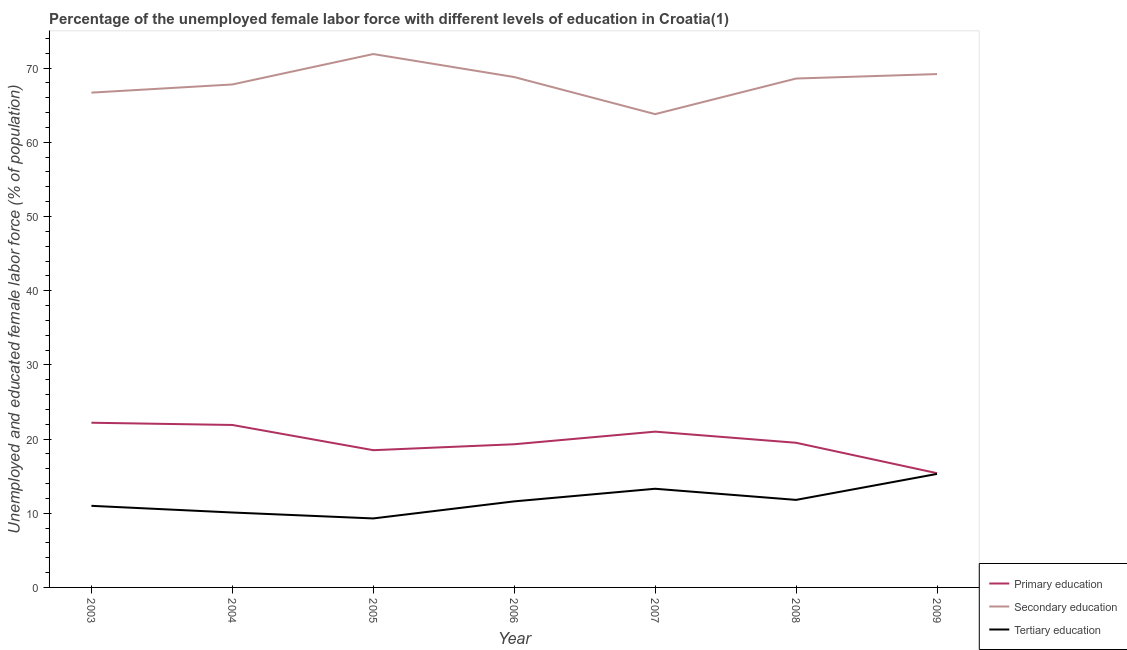Is the number of lines equal to the number of legend labels?
Offer a very short reply. Yes. What is the percentage of female labor force who received secondary education in 2009?
Ensure brevity in your answer.  69.2. Across all years, what is the maximum percentage of female labor force who received tertiary education?
Your answer should be very brief. 15.3. Across all years, what is the minimum percentage of female labor force who received secondary education?
Offer a very short reply. 63.8. What is the total percentage of female labor force who received tertiary education in the graph?
Provide a succinct answer. 82.4. What is the difference between the percentage of female labor force who received secondary education in 2005 and that in 2009?
Give a very brief answer. 2.7. What is the difference between the percentage of female labor force who received primary education in 2007 and the percentage of female labor force who received tertiary education in 2006?
Keep it short and to the point. 9.4. What is the average percentage of female labor force who received primary education per year?
Keep it short and to the point. 19.69. In the year 2008, what is the difference between the percentage of female labor force who received primary education and percentage of female labor force who received tertiary education?
Ensure brevity in your answer.  7.7. What is the ratio of the percentage of female labor force who received tertiary education in 2008 to that in 2009?
Offer a terse response. 0.77. Is the difference between the percentage of female labor force who received primary education in 2005 and 2006 greater than the difference between the percentage of female labor force who received tertiary education in 2005 and 2006?
Make the answer very short. Yes. What is the difference between the highest and the second highest percentage of female labor force who received secondary education?
Make the answer very short. 2.7. What is the difference between the highest and the lowest percentage of female labor force who received tertiary education?
Make the answer very short. 6. Does the percentage of female labor force who received primary education monotonically increase over the years?
Your answer should be compact. No. Is the percentage of female labor force who received primary education strictly less than the percentage of female labor force who received secondary education over the years?
Give a very brief answer. Yes. How many years are there in the graph?
Provide a short and direct response. 7. What is the difference between two consecutive major ticks on the Y-axis?
Offer a very short reply. 10. Does the graph contain any zero values?
Provide a succinct answer. No. How are the legend labels stacked?
Offer a terse response. Vertical. What is the title of the graph?
Provide a short and direct response. Percentage of the unemployed female labor force with different levels of education in Croatia(1). What is the label or title of the X-axis?
Ensure brevity in your answer.  Year. What is the label or title of the Y-axis?
Give a very brief answer. Unemployed and educated female labor force (% of population). What is the Unemployed and educated female labor force (% of population) of Primary education in 2003?
Keep it short and to the point. 22.2. What is the Unemployed and educated female labor force (% of population) of Secondary education in 2003?
Make the answer very short. 66.7. What is the Unemployed and educated female labor force (% of population) of Tertiary education in 2003?
Your response must be concise. 11. What is the Unemployed and educated female labor force (% of population) of Primary education in 2004?
Keep it short and to the point. 21.9. What is the Unemployed and educated female labor force (% of population) of Secondary education in 2004?
Ensure brevity in your answer.  67.8. What is the Unemployed and educated female labor force (% of population) of Tertiary education in 2004?
Offer a terse response. 10.1. What is the Unemployed and educated female labor force (% of population) in Primary education in 2005?
Your answer should be compact. 18.5. What is the Unemployed and educated female labor force (% of population) in Secondary education in 2005?
Offer a very short reply. 71.9. What is the Unemployed and educated female labor force (% of population) of Tertiary education in 2005?
Give a very brief answer. 9.3. What is the Unemployed and educated female labor force (% of population) in Primary education in 2006?
Provide a short and direct response. 19.3. What is the Unemployed and educated female labor force (% of population) of Secondary education in 2006?
Provide a short and direct response. 68.8. What is the Unemployed and educated female labor force (% of population) in Tertiary education in 2006?
Provide a short and direct response. 11.6. What is the Unemployed and educated female labor force (% of population) in Primary education in 2007?
Offer a terse response. 21. What is the Unemployed and educated female labor force (% of population) of Secondary education in 2007?
Offer a terse response. 63.8. What is the Unemployed and educated female labor force (% of population) in Tertiary education in 2007?
Your answer should be very brief. 13.3. What is the Unemployed and educated female labor force (% of population) in Secondary education in 2008?
Your answer should be compact. 68.6. What is the Unemployed and educated female labor force (% of population) in Tertiary education in 2008?
Make the answer very short. 11.8. What is the Unemployed and educated female labor force (% of population) in Primary education in 2009?
Provide a short and direct response. 15.4. What is the Unemployed and educated female labor force (% of population) of Secondary education in 2009?
Your answer should be compact. 69.2. What is the Unemployed and educated female labor force (% of population) in Tertiary education in 2009?
Provide a short and direct response. 15.3. Across all years, what is the maximum Unemployed and educated female labor force (% of population) in Primary education?
Your answer should be compact. 22.2. Across all years, what is the maximum Unemployed and educated female labor force (% of population) in Secondary education?
Offer a terse response. 71.9. Across all years, what is the maximum Unemployed and educated female labor force (% of population) of Tertiary education?
Offer a very short reply. 15.3. Across all years, what is the minimum Unemployed and educated female labor force (% of population) in Primary education?
Provide a short and direct response. 15.4. Across all years, what is the minimum Unemployed and educated female labor force (% of population) in Secondary education?
Make the answer very short. 63.8. Across all years, what is the minimum Unemployed and educated female labor force (% of population) of Tertiary education?
Your answer should be very brief. 9.3. What is the total Unemployed and educated female labor force (% of population) of Primary education in the graph?
Your response must be concise. 137.8. What is the total Unemployed and educated female labor force (% of population) in Secondary education in the graph?
Offer a very short reply. 476.8. What is the total Unemployed and educated female labor force (% of population) in Tertiary education in the graph?
Make the answer very short. 82.4. What is the difference between the Unemployed and educated female labor force (% of population) in Primary education in 2003 and that in 2004?
Give a very brief answer. 0.3. What is the difference between the Unemployed and educated female labor force (% of population) of Tertiary education in 2003 and that in 2004?
Provide a short and direct response. 0.9. What is the difference between the Unemployed and educated female labor force (% of population) in Tertiary education in 2003 and that in 2005?
Your answer should be very brief. 1.7. What is the difference between the Unemployed and educated female labor force (% of population) in Primary education in 2003 and that in 2006?
Make the answer very short. 2.9. What is the difference between the Unemployed and educated female labor force (% of population) in Tertiary education in 2003 and that in 2006?
Make the answer very short. -0.6. What is the difference between the Unemployed and educated female labor force (% of population) in Secondary education in 2003 and that in 2007?
Ensure brevity in your answer.  2.9. What is the difference between the Unemployed and educated female labor force (% of population) in Primary education in 2003 and that in 2008?
Ensure brevity in your answer.  2.7. What is the difference between the Unemployed and educated female labor force (% of population) of Secondary education in 2003 and that in 2008?
Ensure brevity in your answer.  -1.9. What is the difference between the Unemployed and educated female labor force (% of population) in Primary education in 2003 and that in 2009?
Give a very brief answer. 6.8. What is the difference between the Unemployed and educated female labor force (% of population) of Secondary education in 2003 and that in 2009?
Offer a very short reply. -2.5. What is the difference between the Unemployed and educated female labor force (% of population) of Secondary education in 2004 and that in 2005?
Keep it short and to the point. -4.1. What is the difference between the Unemployed and educated female labor force (% of population) of Tertiary education in 2004 and that in 2005?
Keep it short and to the point. 0.8. What is the difference between the Unemployed and educated female labor force (% of population) in Primary education in 2004 and that in 2006?
Your response must be concise. 2.6. What is the difference between the Unemployed and educated female labor force (% of population) in Tertiary education in 2004 and that in 2006?
Offer a very short reply. -1.5. What is the difference between the Unemployed and educated female labor force (% of population) of Primary education in 2004 and that in 2007?
Offer a terse response. 0.9. What is the difference between the Unemployed and educated female labor force (% of population) in Primary education in 2004 and that in 2008?
Provide a short and direct response. 2.4. What is the difference between the Unemployed and educated female labor force (% of population) in Tertiary education in 2004 and that in 2008?
Ensure brevity in your answer.  -1.7. What is the difference between the Unemployed and educated female labor force (% of population) in Secondary education in 2004 and that in 2009?
Your answer should be compact. -1.4. What is the difference between the Unemployed and educated female labor force (% of population) in Primary education in 2005 and that in 2007?
Offer a very short reply. -2.5. What is the difference between the Unemployed and educated female labor force (% of population) of Secondary education in 2005 and that in 2008?
Your answer should be very brief. 3.3. What is the difference between the Unemployed and educated female labor force (% of population) of Secondary education in 2005 and that in 2009?
Your answer should be compact. 2.7. What is the difference between the Unemployed and educated female labor force (% of population) of Primary education in 2006 and that in 2007?
Keep it short and to the point. -1.7. What is the difference between the Unemployed and educated female labor force (% of population) of Secondary education in 2006 and that in 2007?
Your answer should be compact. 5. What is the difference between the Unemployed and educated female labor force (% of population) in Tertiary education in 2006 and that in 2007?
Offer a terse response. -1.7. What is the difference between the Unemployed and educated female labor force (% of population) in Tertiary education in 2006 and that in 2008?
Your answer should be compact. -0.2. What is the difference between the Unemployed and educated female labor force (% of population) in Secondary education in 2006 and that in 2009?
Provide a succinct answer. -0.4. What is the difference between the Unemployed and educated female labor force (% of population) of Primary education in 2007 and that in 2008?
Give a very brief answer. 1.5. What is the difference between the Unemployed and educated female labor force (% of population) of Secondary education in 2007 and that in 2009?
Your response must be concise. -5.4. What is the difference between the Unemployed and educated female labor force (% of population) of Tertiary education in 2007 and that in 2009?
Offer a terse response. -2. What is the difference between the Unemployed and educated female labor force (% of population) of Tertiary education in 2008 and that in 2009?
Your answer should be very brief. -3.5. What is the difference between the Unemployed and educated female labor force (% of population) of Primary education in 2003 and the Unemployed and educated female labor force (% of population) of Secondary education in 2004?
Provide a succinct answer. -45.6. What is the difference between the Unemployed and educated female labor force (% of population) in Secondary education in 2003 and the Unemployed and educated female labor force (% of population) in Tertiary education in 2004?
Give a very brief answer. 56.6. What is the difference between the Unemployed and educated female labor force (% of population) of Primary education in 2003 and the Unemployed and educated female labor force (% of population) of Secondary education in 2005?
Your answer should be very brief. -49.7. What is the difference between the Unemployed and educated female labor force (% of population) in Primary education in 2003 and the Unemployed and educated female labor force (% of population) in Tertiary education in 2005?
Your response must be concise. 12.9. What is the difference between the Unemployed and educated female labor force (% of population) in Secondary education in 2003 and the Unemployed and educated female labor force (% of population) in Tertiary education in 2005?
Your answer should be compact. 57.4. What is the difference between the Unemployed and educated female labor force (% of population) in Primary education in 2003 and the Unemployed and educated female labor force (% of population) in Secondary education in 2006?
Keep it short and to the point. -46.6. What is the difference between the Unemployed and educated female labor force (% of population) of Secondary education in 2003 and the Unemployed and educated female labor force (% of population) of Tertiary education in 2006?
Give a very brief answer. 55.1. What is the difference between the Unemployed and educated female labor force (% of population) in Primary education in 2003 and the Unemployed and educated female labor force (% of population) in Secondary education in 2007?
Keep it short and to the point. -41.6. What is the difference between the Unemployed and educated female labor force (% of population) in Primary education in 2003 and the Unemployed and educated female labor force (% of population) in Tertiary education in 2007?
Ensure brevity in your answer.  8.9. What is the difference between the Unemployed and educated female labor force (% of population) in Secondary education in 2003 and the Unemployed and educated female labor force (% of population) in Tertiary education in 2007?
Offer a terse response. 53.4. What is the difference between the Unemployed and educated female labor force (% of population) in Primary education in 2003 and the Unemployed and educated female labor force (% of population) in Secondary education in 2008?
Keep it short and to the point. -46.4. What is the difference between the Unemployed and educated female labor force (% of population) in Primary education in 2003 and the Unemployed and educated female labor force (% of population) in Tertiary education in 2008?
Offer a terse response. 10.4. What is the difference between the Unemployed and educated female labor force (% of population) of Secondary education in 2003 and the Unemployed and educated female labor force (% of population) of Tertiary education in 2008?
Ensure brevity in your answer.  54.9. What is the difference between the Unemployed and educated female labor force (% of population) in Primary education in 2003 and the Unemployed and educated female labor force (% of population) in Secondary education in 2009?
Offer a terse response. -47. What is the difference between the Unemployed and educated female labor force (% of population) of Secondary education in 2003 and the Unemployed and educated female labor force (% of population) of Tertiary education in 2009?
Give a very brief answer. 51.4. What is the difference between the Unemployed and educated female labor force (% of population) of Primary education in 2004 and the Unemployed and educated female labor force (% of population) of Secondary education in 2005?
Keep it short and to the point. -50. What is the difference between the Unemployed and educated female labor force (% of population) in Secondary education in 2004 and the Unemployed and educated female labor force (% of population) in Tertiary education in 2005?
Make the answer very short. 58.5. What is the difference between the Unemployed and educated female labor force (% of population) in Primary education in 2004 and the Unemployed and educated female labor force (% of population) in Secondary education in 2006?
Offer a terse response. -46.9. What is the difference between the Unemployed and educated female labor force (% of population) in Primary education in 2004 and the Unemployed and educated female labor force (% of population) in Tertiary education in 2006?
Keep it short and to the point. 10.3. What is the difference between the Unemployed and educated female labor force (% of population) in Secondary education in 2004 and the Unemployed and educated female labor force (% of population) in Tertiary education in 2006?
Make the answer very short. 56.2. What is the difference between the Unemployed and educated female labor force (% of population) in Primary education in 2004 and the Unemployed and educated female labor force (% of population) in Secondary education in 2007?
Offer a terse response. -41.9. What is the difference between the Unemployed and educated female labor force (% of population) of Secondary education in 2004 and the Unemployed and educated female labor force (% of population) of Tertiary education in 2007?
Provide a succinct answer. 54.5. What is the difference between the Unemployed and educated female labor force (% of population) in Primary education in 2004 and the Unemployed and educated female labor force (% of population) in Secondary education in 2008?
Your response must be concise. -46.7. What is the difference between the Unemployed and educated female labor force (% of population) of Secondary education in 2004 and the Unemployed and educated female labor force (% of population) of Tertiary education in 2008?
Keep it short and to the point. 56. What is the difference between the Unemployed and educated female labor force (% of population) of Primary education in 2004 and the Unemployed and educated female labor force (% of population) of Secondary education in 2009?
Offer a terse response. -47.3. What is the difference between the Unemployed and educated female labor force (% of population) in Secondary education in 2004 and the Unemployed and educated female labor force (% of population) in Tertiary education in 2009?
Your answer should be compact. 52.5. What is the difference between the Unemployed and educated female labor force (% of population) in Primary education in 2005 and the Unemployed and educated female labor force (% of population) in Secondary education in 2006?
Ensure brevity in your answer.  -50.3. What is the difference between the Unemployed and educated female labor force (% of population) in Primary education in 2005 and the Unemployed and educated female labor force (% of population) in Tertiary education in 2006?
Offer a terse response. 6.9. What is the difference between the Unemployed and educated female labor force (% of population) of Secondary education in 2005 and the Unemployed and educated female labor force (% of population) of Tertiary education in 2006?
Offer a terse response. 60.3. What is the difference between the Unemployed and educated female labor force (% of population) of Primary education in 2005 and the Unemployed and educated female labor force (% of population) of Secondary education in 2007?
Your answer should be very brief. -45.3. What is the difference between the Unemployed and educated female labor force (% of population) in Secondary education in 2005 and the Unemployed and educated female labor force (% of population) in Tertiary education in 2007?
Provide a succinct answer. 58.6. What is the difference between the Unemployed and educated female labor force (% of population) of Primary education in 2005 and the Unemployed and educated female labor force (% of population) of Secondary education in 2008?
Provide a succinct answer. -50.1. What is the difference between the Unemployed and educated female labor force (% of population) in Primary education in 2005 and the Unemployed and educated female labor force (% of population) in Tertiary education in 2008?
Offer a very short reply. 6.7. What is the difference between the Unemployed and educated female labor force (% of population) of Secondary education in 2005 and the Unemployed and educated female labor force (% of population) of Tertiary education in 2008?
Your answer should be compact. 60.1. What is the difference between the Unemployed and educated female labor force (% of population) in Primary education in 2005 and the Unemployed and educated female labor force (% of population) in Secondary education in 2009?
Your answer should be very brief. -50.7. What is the difference between the Unemployed and educated female labor force (% of population) in Secondary education in 2005 and the Unemployed and educated female labor force (% of population) in Tertiary education in 2009?
Give a very brief answer. 56.6. What is the difference between the Unemployed and educated female labor force (% of population) of Primary education in 2006 and the Unemployed and educated female labor force (% of population) of Secondary education in 2007?
Offer a terse response. -44.5. What is the difference between the Unemployed and educated female labor force (% of population) in Primary education in 2006 and the Unemployed and educated female labor force (% of population) in Tertiary education in 2007?
Offer a very short reply. 6. What is the difference between the Unemployed and educated female labor force (% of population) in Secondary education in 2006 and the Unemployed and educated female labor force (% of population) in Tertiary education in 2007?
Your response must be concise. 55.5. What is the difference between the Unemployed and educated female labor force (% of population) of Primary education in 2006 and the Unemployed and educated female labor force (% of population) of Secondary education in 2008?
Offer a terse response. -49.3. What is the difference between the Unemployed and educated female labor force (% of population) in Primary education in 2006 and the Unemployed and educated female labor force (% of population) in Tertiary education in 2008?
Give a very brief answer. 7.5. What is the difference between the Unemployed and educated female labor force (% of population) in Primary education in 2006 and the Unemployed and educated female labor force (% of population) in Secondary education in 2009?
Keep it short and to the point. -49.9. What is the difference between the Unemployed and educated female labor force (% of population) of Primary education in 2006 and the Unemployed and educated female labor force (% of population) of Tertiary education in 2009?
Provide a short and direct response. 4. What is the difference between the Unemployed and educated female labor force (% of population) of Secondary education in 2006 and the Unemployed and educated female labor force (% of population) of Tertiary education in 2009?
Your answer should be compact. 53.5. What is the difference between the Unemployed and educated female labor force (% of population) in Primary education in 2007 and the Unemployed and educated female labor force (% of population) in Secondary education in 2008?
Make the answer very short. -47.6. What is the difference between the Unemployed and educated female labor force (% of population) in Primary education in 2007 and the Unemployed and educated female labor force (% of population) in Tertiary education in 2008?
Provide a succinct answer. 9.2. What is the difference between the Unemployed and educated female labor force (% of population) in Primary education in 2007 and the Unemployed and educated female labor force (% of population) in Secondary education in 2009?
Your answer should be compact. -48.2. What is the difference between the Unemployed and educated female labor force (% of population) in Secondary education in 2007 and the Unemployed and educated female labor force (% of population) in Tertiary education in 2009?
Keep it short and to the point. 48.5. What is the difference between the Unemployed and educated female labor force (% of population) in Primary education in 2008 and the Unemployed and educated female labor force (% of population) in Secondary education in 2009?
Your answer should be compact. -49.7. What is the difference between the Unemployed and educated female labor force (% of population) in Primary education in 2008 and the Unemployed and educated female labor force (% of population) in Tertiary education in 2009?
Your answer should be compact. 4.2. What is the difference between the Unemployed and educated female labor force (% of population) of Secondary education in 2008 and the Unemployed and educated female labor force (% of population) of Tertiary education in 2009?
Provide a short and direct response. 53.3. What is the average Unemployed and educated female labor force (% of population) in Primary education per year?
Your answer should be compact. 19.69. What is the average Unemployed and educated female labor force (% of population) of Secondary education per year?
Provide a succinct answer. 68.11. What is the average Unemployed and educated female labor force (% of population) of Tertiary education per year?
Offer a terse response. 11.77. In the year 2003, what is the difference between the Unemployed and educated female labor force (% of population) of Primary education and Unemployed and educated female labor force (% of population) of Secondary education?
Your answer should be very brief. -44.5. In the year 2003, what is the difference between the Unemployed and educated female labor force (% of population) of Secondary education and Unemployed and educated female labor force (% of population) of Tertiary education?
Keep it short and to the point. 55.7. In the year 2004, what is the difference between the Unemployed and educated female labor force (% of population) of Primary education and Unemployed and educated female labor force (% of population) of Secondary education?
Keep it short and to the point. -45.9. In the year 2004, what is the difference between the Unemployed and educated female labor force (% of population) in Secondary education and Unemployed and educated female labor force (% of population) in Tertiary education?
Give a very brief answer. 57.7. In the year 2005, what is the difference between the Unemployed and educated female labor force (% of population) of Primary education and Unemployed and educated female labor force (% of population) of Secondary education?
Ensure brevity in your answer.  -53.4. In the year 2005, what is the difference between the Unemployed and educated female labor force (% of population) of Secondary education and Unemployed and educated female labor force (% of population) of Tertiary education?
Offer a very short reply. 62.6. In the year 2006, what is the difference between the Unemployed and educated female labor force (% of population) of Primary education and Unemployed and educated female labor force (% of population) of Secondary education?
Your answer should be compact. -49.5. In the year 2006, what is the difference between the Unemployed and educated female labor force (% of population) in Secondary education and Unemployed and educated female labor force (% of population) in Tertiary education?
Offer a terse response. 57.2. In the year 2007, what is the difference between the Unemployed and educated female labor force (% of population) of Primary education and Unemployed and educated female labor force (% of population) of Secondary education?
Make the answer very short. -42.8. In the year 2007, what is the difference between the Unemployed and educated female labor force (% of population) of Primary education and Unemployed and educated female labor force (% of population) of Tertiary education?
Your response must be concise. 7.7. In the year 2007, what is the difference between the Unemployed and educated female labor force (% of population) in Secondary education and Unemployed and educated female labor force (% of population) in Tertiary education?
Provide a short and direct response. 50.5. In the year 2008, what is the difference between the Unemployed and educated female labor force (% of population) of Primary education and Unemployed and educated female labor force (% of population) of Secondary education?
Offer a terse response. -49.1. In the year 2008, what is the difference between the Unemployed and educated female labor force (% of population) of Primary education and Unemployed and educated female labor force (% of population) of Tertiary education?
Your answer should be very brief. 7.7. In the year 2008, what is the difference between the Unemployed and educated female labor force (% of population) of Secondary education and Unemployed and educated female labor force (% of population) of Tertiary education?
Your answer should be compact. 56.8. In the year 2009, what is the difference between the Unemployed and educated female labor force (% of population) in Primary education and Unemployed and educated female labor force (% of population) in Secondary education?
Keep it short and to the point. -53.8. In the year 2009, what is the difference between the Unemployed and educated female labor force (% of population) in Secondary education and Unemployed and educated female labor force (% of population) in Tertiary education?
Your response must be concise. 53.9. What is the ratio of the Unemployed and educated female labor force (% of population) of Primary education in 2003 to that in 2004?
Your answer should be very brief. 1.01. What is the ratio of the Unemployed and educated female labor force (% of population) of Secondary education in 2003 to that in 2004?
Provide a succinct answer. 0.98. What is the ratio of the Unemployed and educated female labor force (% of population) in Tertiary education in 2003 to that in 2004?
Offer a terse response. 1.09. What is the ratio of the Unemployed and educated female labor force (% of population) in Secondary education in 2003 to that in 2005?
Provide a succinct answer. 0.93. What is the ratio of the Unemployed and educated female labor force (% of population) in Tertiary education in 2003 to that in 2005?
Your response must be concise. 1.18. What is the ratio of the Unemployed and educated female labor force (% of population) of Primary education in 2003 to that in 2006?
Provide a succinct answer. 1.15. What is the ratio of the Unemployed and educated female labor force (% of population) in Secondary education in 2003 to that in 2006?
Provide a succinct answer. 0.97. What is the ratio of the Unemployed and educated female labor force (% of population) in Tertiary education in 2003 to that in 2006?
Keep it short and to the point. 0.95. What is the ratio of the Unemployed and educated female labor force (% of population) in Primary education in 2003 to that in 2007?
Offer a terse response. 1.06. What is the ratio of the Unemployed and educated female labor force (% of population) of Secondary education in 2003 to that in 2007?
Provide a succinct answer. 1.05. What is the ratio of the Unemployed and educated female labor force (% of population) in Tertiary education in 2003 to that in 2007?
Offer a terse response. 0.83. What is the ratio of the Unemployed and educated female labor force (% of population) of Primary education in 2003 to that in 2008?
Give a very brief answer. 1.14. What is the ratio of the Unemployed and educated female labor force (% of population) of Secondary education in 2003 to that in 2008?
Give a very brief answer. 0.97. What is the ratio of the Unemployed and educated female labor force (% of population) of Tertiary education in 2003 to that in 2008?
Provide a succinct answer. 0.93. What is the ratio of the Unemployed and educated female labor force (% of population) of Primary education in 2003 to that in 2009?
Make the answer very short. 1.44. What is the ratio of the Unemployed and educated female labor force (% of population) in Secondary education in 2003 to that in 2009?
Your answer should be very brief. 0.96. What is the ratio of the Unemployed and educated female labor force (% of population) of Tertiary education in 2003 to that in 2009?
Offer a terse response. 0.72. What is the ratio of the Unemployed and educated female labor force (% of population) of Primary education in 2004 to that in 2005?
Offer a terse response. 1.18. What is the ratio of the Unemployed and educated female labor force (% of population) of Secondary education in 2004 to that in 2005?
Your answer should be very brief. 0.94. What is the ratio of the Unemployed and educated female labor force (% of population) of Tertiary education in 2004 to that in 2005?
Your answer should be compact. 1.09. What is the ratio of the Unemployed and educated female labor force (% of population) of Primary education in 2004 to that in 2006?
Provide a short and direct response. 1.13. What is the ratio of the Unemployed and educated female labor force (% of population) of Secondary education in 2004 to that in 2006?
Keep it short and to the point. 0.99. What is the ratio of the Unemployed and educated female labor force (% of population) in Tertiary education in 2004 to that in 2006?
Offer a very short reply. 0.87. What is the ratio of the Unemployed and educated female labor force (% of population) of Primary education in 2004 to that in 2007?
Give a very brief answer. 1.04. What is the ratio of the Unemployed and educated female labor force (% of population) in Secondary education in 2004 to that in 2007?
Give a very brief answer. 1.06. What is the ratio of the Unemployed and educated female labor force (% of population) in Tertiary education in 2004 to that in 2007?
Your response must be concise. 0.76. What is the ratio of the Unemployed and educated female labor force (% of population) of Primary education in 2004 to that in 2008?
Your response must be concise. 1.12. What is the ratio of the Unemployed and educated female labor force (% of population) of Secondary education in 2004 to that in 2008?
Offer a very short reply. 0.99. What is the ratio of the Unemployed and educated female labor force (% of population) of Tertiary education in 2004 to that in 2008?
Your response must be concise. 0.86. What is the ratio of the Unemployed and educated female labor force (% of population) of Primary education in 2004 to that in 2009?
Provide a short and direct response. 1.42. What is the ratio of the Unemployed and educated female labor force (% of population) of Secondary education in 2004 to that in 2009?
Keep it short and to the point. 0.98. What is the ratio of the Unemployed and educated female labor force (% of population) in Tertiary education in 2004 to that in 2009?
Offer a very short reply. 0.66. What is the ratio of the Unemployed and educated female labor force (% of population) of Primary education in 2005 to that in 2006?
Keep it short and to the point. 0.96. What is the ratio of the Unemployed and educated female labor force (% of population) of Secondary education in 2005 to that in 2006?
Ensure brevity in your answer.  1.05. What is the ratio of the Unemployed and educated female labor force (% of population) of Tertiary education in 2005 to that in 2006?
Ensure brevity in your answer.  0.8. What is the ratio of the Unemployed and educated female labor force (% of population) in Primary education in 2005 to that in 2007?
Your response must be concise. 0.88. What is the ratio of the Unemployed and educated female labor force (% of population) of Secondary education in 2005 to that in 2007?
Your response must be concise. 1.13. What is the ratio of the Unemployed and educated female labor force (% of population) of Tertiary education in 2005 to that in 2007?
Provide a succinct answer. 0.7. What is the ratio of the Unemployed and educated female labor force (% of population) of Primary education in 2005 to that in 2008?
Offer a terse response. 0.95. What is the ratio of the Unemployed and educated female labor force (% of population) of Secondary education in 2005 to that in 2008?
Offer a very short reply. 1.05. What is the ratio of the Unemployed and educated female labor force (% of population) in Tertiary education in 2005 to that in 2008?
Offer a very short reply. 0.79. What is the ratio of the Unemployed and educated female labor force (% of population) of Primary education in 2005 to that in 2009?
Make the answer very short. 1.2. What is the ratio of the Unemployed and educated female labor force (% of population) of Secondary education in 2005 to that in 2009?
Your response must be concise. 1.04. What is the ratio of the Unemployed and educated female labor force (% of population) of Tertiary education in 2005 to that in 2009?
Your response must be concise. 0.61. What is the ratio of the Unemployed and educated female labor force (% of population) in Primary education in 2006 to that in 2007?
Provide a succinct answer. 0.92. What is the ratio of the Unemployed and educated female labor force (% of population) of Secondary education in 2006 to that in 2007?
Offer a very short reply. 1.08. What is the ratio of the Unemployed and educated female labor force (% of population) of Tertiary education in 2006 to that in 2007?
Ensure brevity in your answer.  0.87. What is the ratio of the Unemployed and educated female labor force (% of population) in Tertiary education in 2006 to that in 2008?
Offer a very short reply. 0.98. What is the ratio of the Unemployed and educated female labor force (% of population) of Primary education in 2006 to that in 2009?
Make the answer very short. 1.25. What is the ratio of the Unemployed and educated female labor force (% of population) of Secondary education in 2006 to that in 2009?
Give a very brief answer. 0.99. What is the ratio of the Unemployed and educated female labor force (% of population) in Tertiary education in 2006 to that in 2009?
Your answer should be compact. 0.76. What is the ratio of the Unemployed and educated female labor force (% of population) of Primary education in 2007 to that in 2008?
Keep it short and to the point. 1.08. What is the ratio of the Unemployed and educated female labor force (% of population) of Tertiary education in 2007 to that in 2008?
Your answer should be compact. 1.13. What is the ratio of the Unemployed and educated female labor force (% of population) of Primary education in 2007 to that in 2009?
Keep it short and to the point. 1.36. What is the ratio of the Unemployed and educated female labor force (% of population) of Secondary education in 2007 to that in 2009?
Give a very brief answer. 0.92. What is the ratio of the Unemployed and educated female labor force (% of population) in Tertiary education in 2007 to that in 2009?
Your answer should be compact. 0.87. What is the ratio of the Unemployed and educated female labor force (% of population) of Primary education in 2008 to that in 2009?
Your response must be concise. 1.27. What is the ratio of the Unemployed and educated female labor force (% of population) in Tertiary education in 2008 to that in 2009?
Ensure brevity in your answer.  0.77. What is the difference between the highest and the lowest Unemployed and educated female labor force (% of population) in Primary education?
Give a very brief answer. 6.8. 